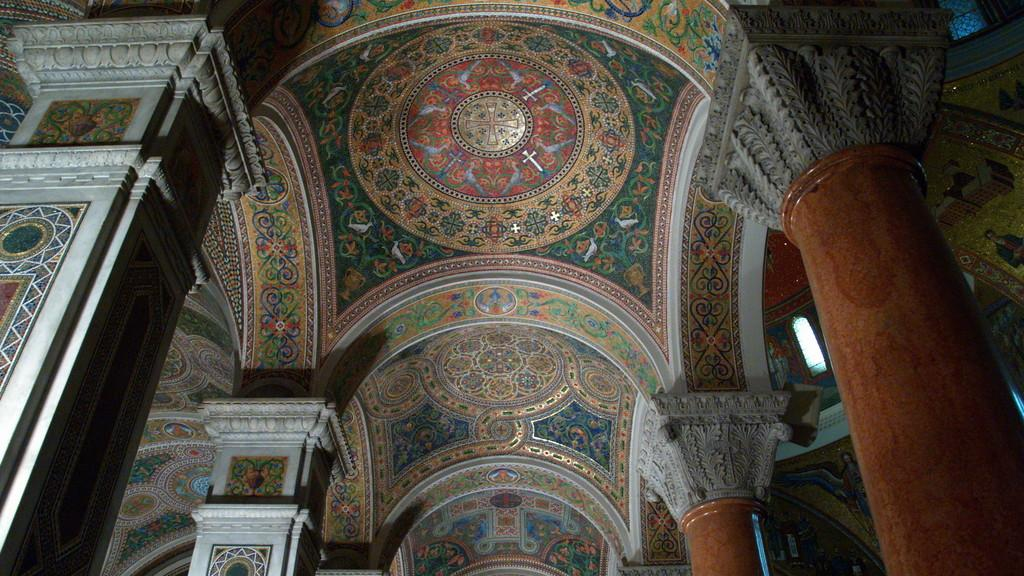What is the main structure visible in the image? The main structure visible in the image is the roof of a building. Are there any supporting elements visible under the roof? Yes, there are pillars under the roof in the image. What type of wrench is the queen using to fix the roof in the image? There is no queen or wrench present in the image; it only features the roof and pillars of a building. 